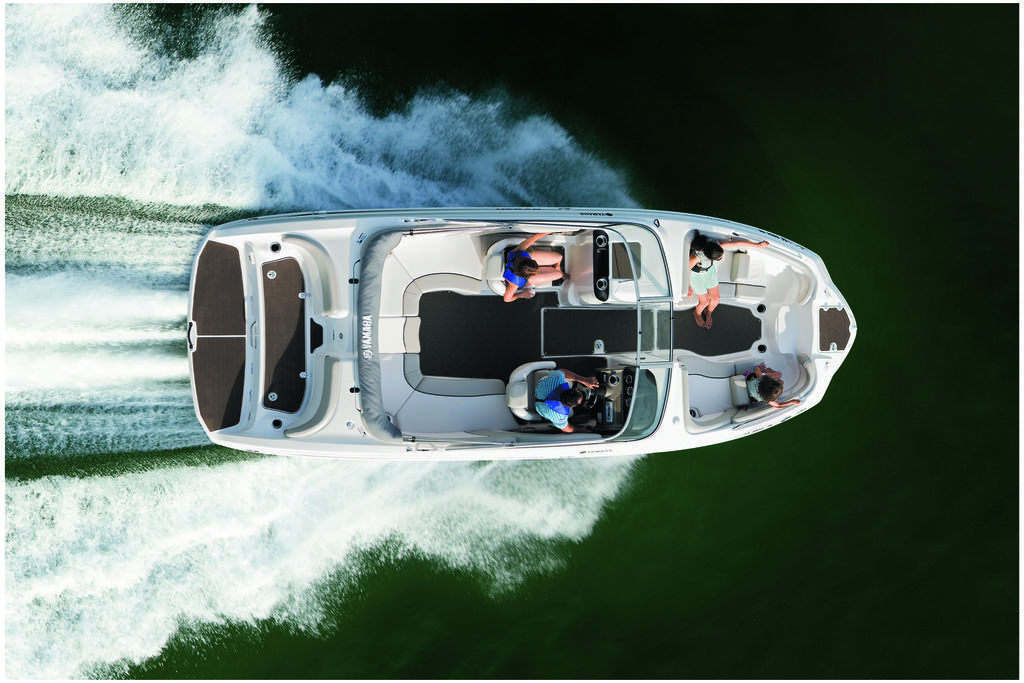Can you describe this image briefly? In this image I can see a boat on the water. I can see four persons sitting in the boat. 